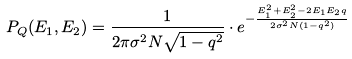<formula> <loc_0><loc_0><loc_500><loc_500>P _ { Q } ( E _ { 1 } , E _ { 2 } ) = \frac { 1 } { 2 \pi \sigma ^ { 2 } N \sqrt { 1 - q ^ { 2 } } } \cdot e ^ { - \frac { E _ { 1 } ^ { 2 } + E _ { 2 } ^ { 2 } - 2 E _ { 1 } E _ { 2 } q } { 2 \sigma ^ { 2 } N ( 1 - q ^ { 2 } ) } }</formula> 